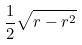Convert formula to latex. <formula><loc_0><loc_0><loc_500><loc_500>\frac { 1 } { 2 } \sqrt { r - r ^ { 2 } }</formula> 